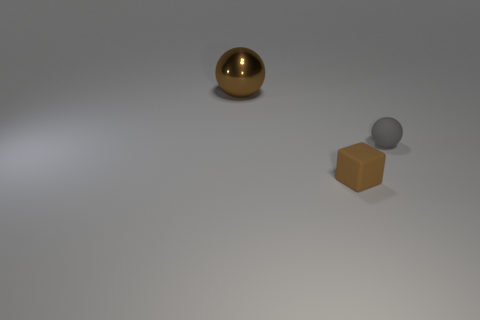Subtract all gray spheres. How many spheres are left? 1 Add 1 tiny purple spheres. How many objects exist? 4 Subtract 1 cubes. How many cubes are left? 0 Subtract all cyan balls. Subtract all yellow cylinders. How many balls are left? 2 Subtract all green cubes. How many gray spheres are left? 1 Subtract all brown rubber cubes. Subtract all small brown objects. How many objects are left? 1 Add 3 large brown metal balls. How many large brown metal balls are left? 4 Add 2 brown shiny objects. How many brown shiny objects exist? 3 Subtract 0 gray cylinders. How many objects are left? 3 Subtract all balls. How many objects are left? 1 